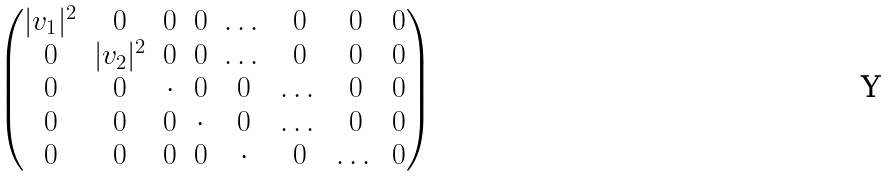Convert formula to latex. <formula><loc_0><loc_0><loc_500><loc_500>\begin{pmatrix} | v _ { 1 } | ^ { 2 } & 0 & 0 & 0 & \dots & 0 & 0 & 0 \\ 0 & | v _ { 2 } | ^ { 2 } & 0 & 0 & \dots & 0 & 0 & 0 \\ 0 & 0 & \cdot & 0 & 0 & \dots & 0 & 0 \\ 0 & 0 & 0 & \cdot & 0 & \dots & 0 & 0 \\ 0 & 0 & 0 & 0 & \cdot & 0 & \dots & 0 \\ \end{pmatrix}</formula> 